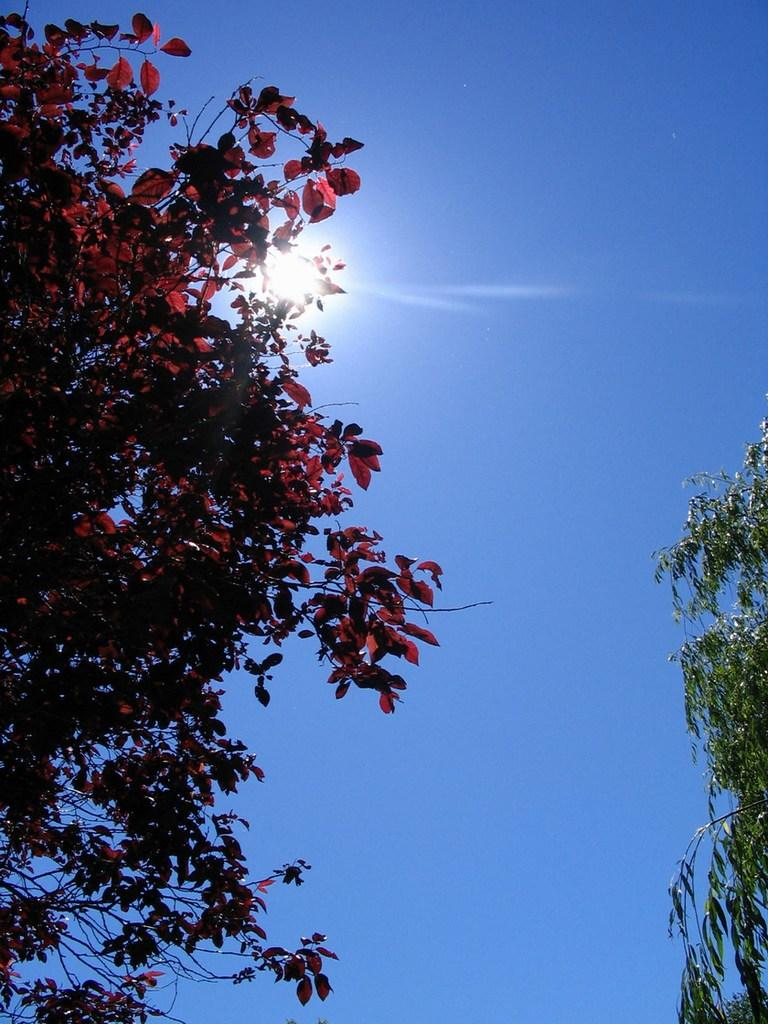What type of tree is in the foreground of the image? There is a tree with red leaves in the foreground of the image. Are there any other trees visible in the image? Yes, there is another tree on the right side of the image. What can be seen in the background of the image? The sky is visible in the background of the image. What celestial body is observable in the sky? The sun is observable in the sky. What type of dirt can be seen on the leaves of the tree in the image? There is no dirt visible on the leaves of the tree in the image. What type of lead is used to create the red color of the leaves in the image? The leaves in the image are naturally red and do not require any lead to create their color. 